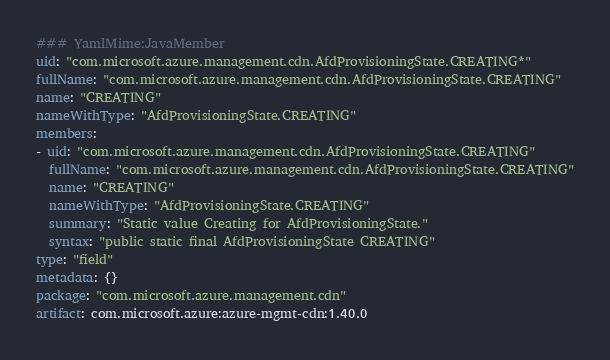Convert code to text. <code><loc_0><loc_0><loc_500><loc_500><_YAML_>### YamlMime:JavaMember
uid: "com.microsoft.azure.management.cdn.AfdProvisioningState.CREATING*"
fullName: "com.microsoft.azure.management.cdn.AfdProvisioningState.CREATING"
name: "CREATING"
nameWithType: "AfdProvisioningState.CREATING"
members:
- uid: "com.microsoft.azure.management.cdn.AfdProvisioningState.CREATING"
  fullName: "com.microsoft.azure.management.cdn.AfdProvisioningState.CREATING"
  name: "CREATING"
  nameWithType: "AfdProvisioningState.CREATING"
  summary: "Static value Creating for AfdProvisioningState."
  syntax: "public static final AfdProvisioningState CREATING"
type: "field"
metadata: {}
package: "com.microsoft.azure.management.cdn"
artifact: com.microsoft.azure:azure-mgmt-cdn:1.40.0
</code> 